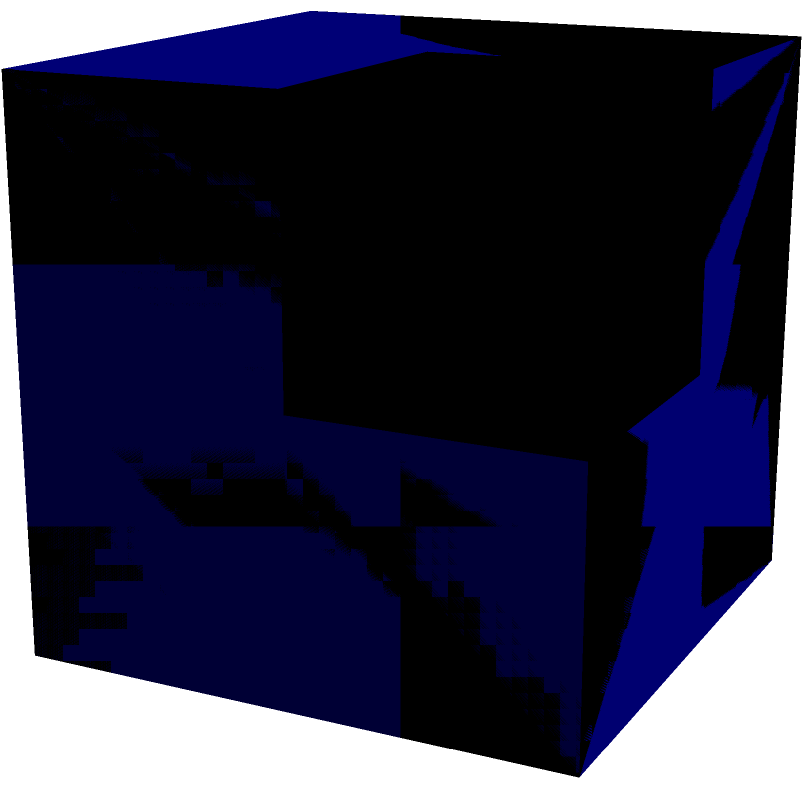As a student of Al-Farabi Kazakh National University, you're tasked with analyzing a 3D structure for a university project. The structure is composed of cubes arranged in a 2x2x2 grid, but one cube is missing. Based on the given perspective view, how many cubes are present in the structure? Let's analyze this step-by-step:

1. First, we need to understand the maximum capacity of the structure. A 2x2x2 grid can hold a maximum of $2 \times 2 \times 2 = 8$ cubes.

2. Looking at the bottom layer:
   - We can see 4 cubes forming a complete 2x2 square.

3. Looking at the top layer:
   - We can see 3 cubes.
   - There's a visible gap in the top-right corner when viewed from this perspective.

4. Counting the visible cubes:
   - Bottom layer: 4 cubes
   - Top layer: 3 cubes
   - Total visible: $4 + 3 = 7$ cubes

5. Verifying with the maximum capacity:
   - Maximum capacity: 8 cubes
   - Visible cubes: 7 cubes
   - Missing cubes: $8 - 7 = 1$ cube

Therefore, the structure contains 7 cubes.
Answer: 7 cubes 